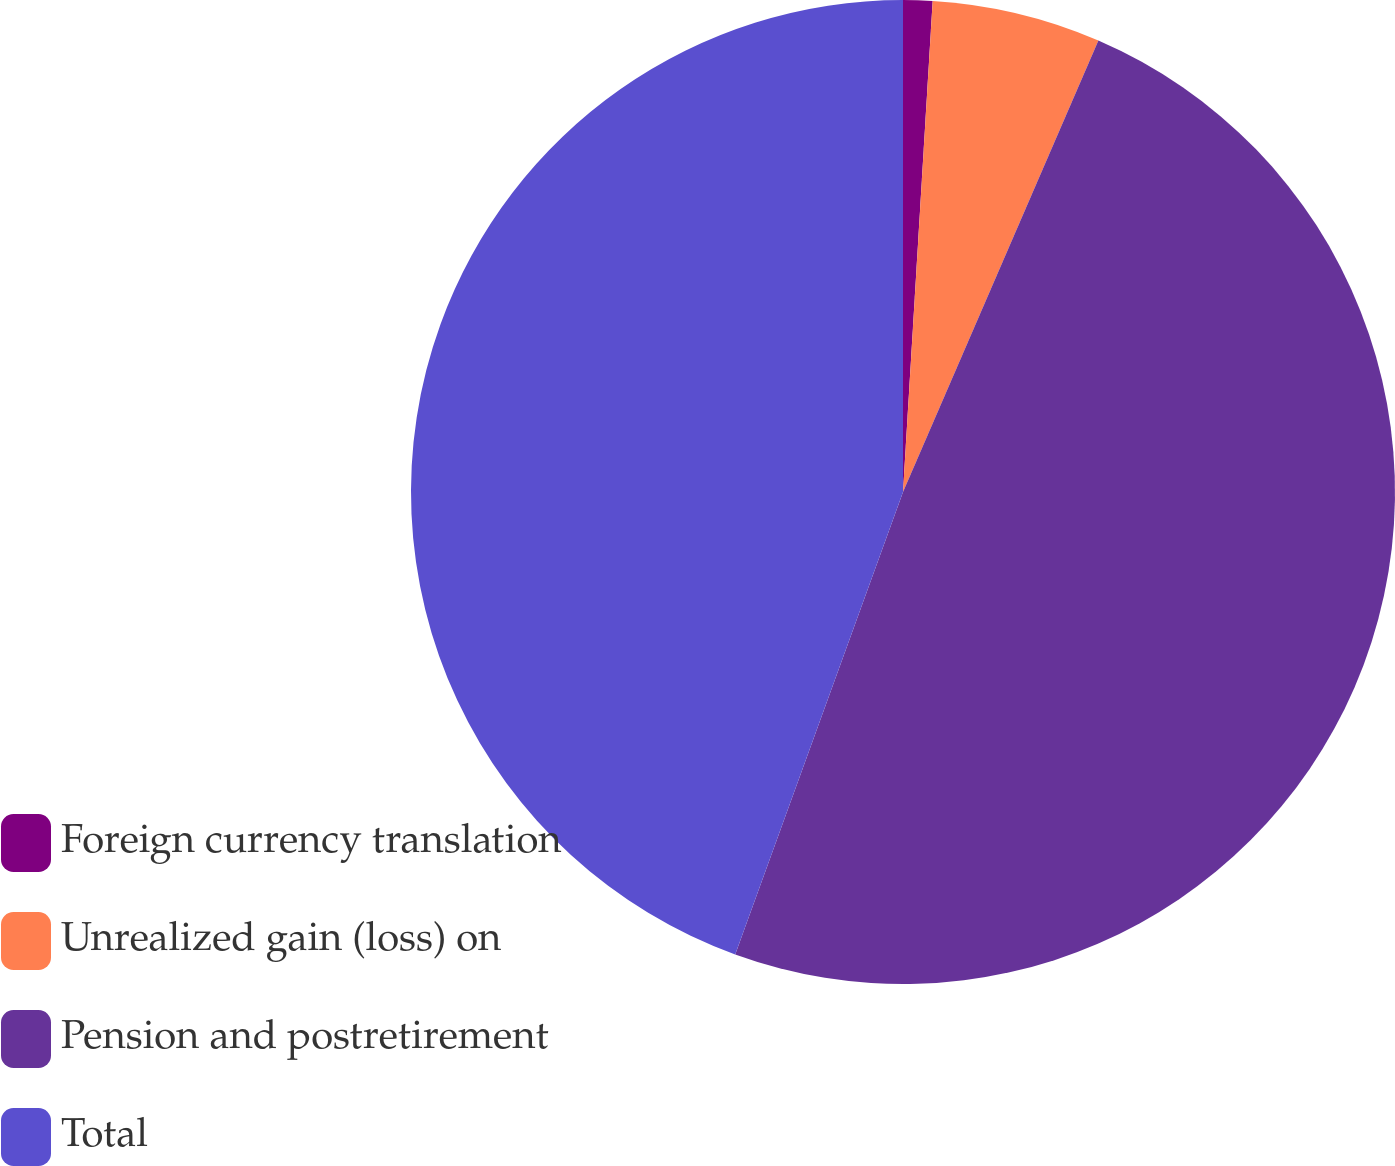Convert chart. <chart><loc_0><loc_0><loc_500><loc_500><pie_chart><fcel>Foreign currency translation<fcel>Unrealized gain (loss) on<fcel>Pension and postretirement<fcel>Total<nl><fcel>0.96%<fcel>5.54%<fcel>49.04%<fcel>44.46%<nl></chart> 